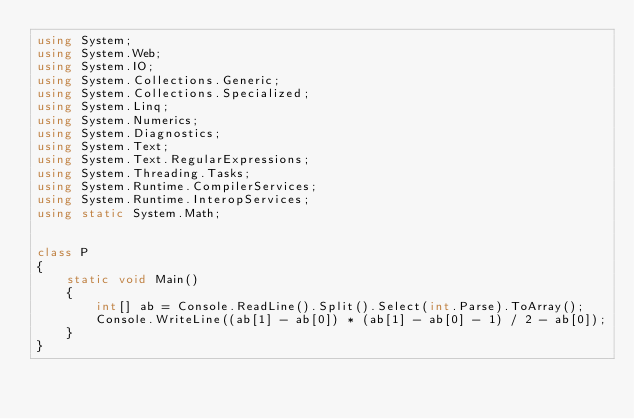<code> <loc_0><loc_0><loc_500><loc_500><_C#_>using System;
using System.Web;
using System.IO;
using System.Collections.Generic;
using System.Collections.Specialized;
using System.Linq;
using System.Numerics;
using System.Diagnostics;
using System.Text;
using System.Text.RegularExpressions;
using System.Threading.Tasks;
using System.Runtime.CompilerServices;
using System.Runtime.InteropServices;
using static System.Math;
 

class P
{
    static void Main()
    {
        int[] ab = Console.ReadLine().Split().Select(int.Parse).ToArray();
        Console.WriteLine((ab[1] - ab[0]) * (ab[1] - ab[0] - 1) / 2 - ab[0]);
    }
}
</code> 